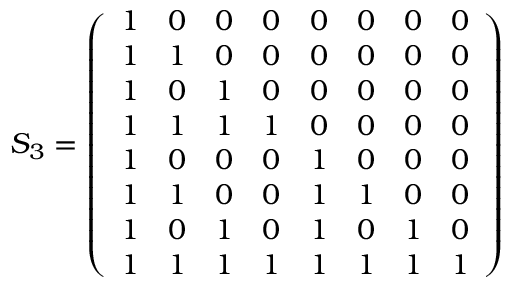Convert formula to latex. <formula><loc_0><loc_0><loc_500><loc_500>S _ { 3 } = { \left ( \begin{array} { l l l l l l l l } { 1 } & { 0 } & { 0 } & { 0 } & { 0 } & { 0 } & { 0 } & { 0 } \\ { 1 } & { 1 } & { 0 } & { 0 } & { 0 } & { 0 } & { 0 } & { 0 } \\ { 1 } & { 0 } & { 1 } & { 0 } & { 0 } & { 0 } & { 0 } & { 0 } \\ { 1 } & { 1 } & { 1 } & { 1 } & { 0 } & { 0 } & { 0 } & { 0 } \\ { 1 } & { 0 } & { 0 } & { 0 } & { 1 } & { 0 } & { 0 } & { 0 } \\ { 1 } & { 1 } & { 0 } & { 0 } & { 1 } & { 1 } & { 0 } & { 0 } \\ { 1 } & { 0 } & { 1 } & { 0 } & { 1 } & { 0 } & { 1 } & { 0 } \\ { 1 } & { 1 } & { 1 } & { 1 } & { 1 } & { 1 } & { 1 } & { 1 } \end{array} \right ) }</formula> 